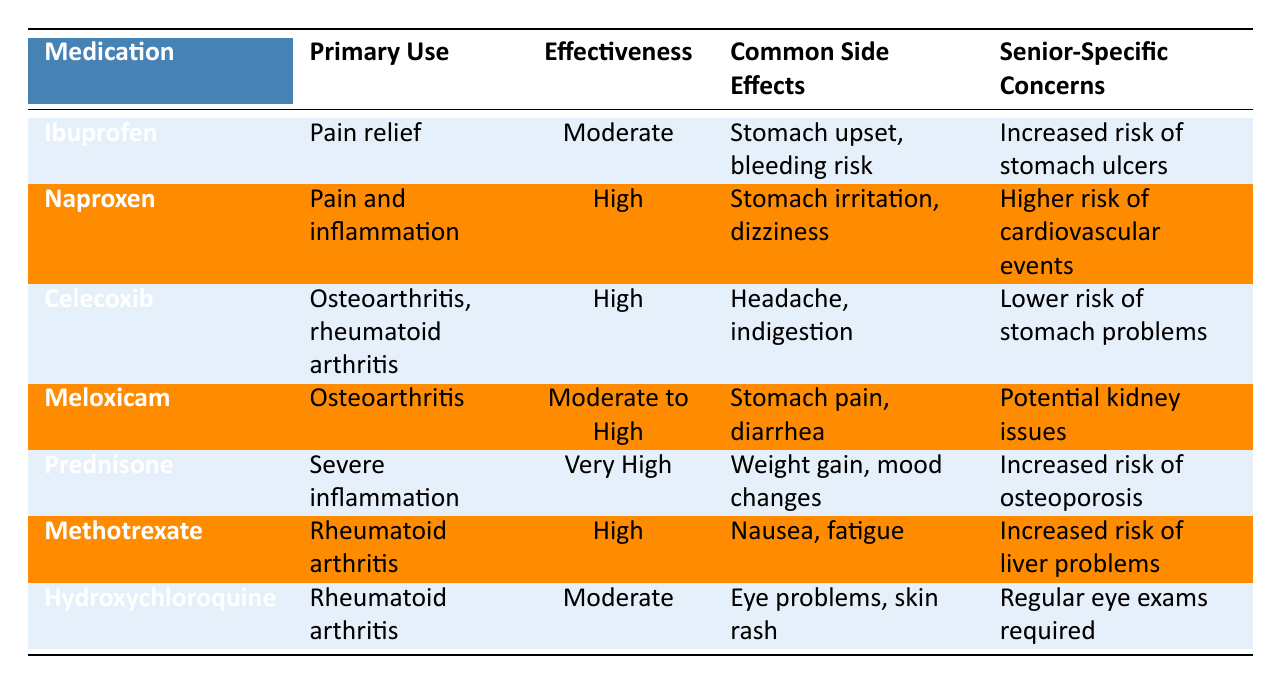What is the effectiveness rating of Prednisone? The table shows that the effectiveness rating of Prednisone is listed as "Very High."
Answer: Very High Which medication has a lower risk of stomach problems? The table indicates that Celecoxib has a "Lower risk of stomach problems" noted in its senior-specific concerns.
Answer: Celecoxib Is Meloxicam used for rheumatoid arthritis? The primary use of Meloxicam, according to the table, is "Osteoarthritis," indicating it is not specifically used for rheumatoid arthritis.
Answer: No What are the common side effects of Naproxen? According to the table, the common side effects listed for Naproxen are "Stomach irritation, dizziness."
Answer: Stomach irritation, dizziness How does the effectiveness of Methotrexate compare to Ibuprofen? The effectiveness rating for Methotrexate is "High," while for Ibuprofen it is "Moderate." Thus, Methotrexate is more effective than Ibuprofen.
Answer: Methotrexate is more effective Which medication has the highest effectiveness for severe inflammation? The table shows that Prednisone has the highest effectiveness rating listed as "Very High" for severe inflammation.
Answer: Prednisone Are the common side effects of Hydroxychloroquine worse than those of Celecoxib? Hydroxychloroquine has side effects of "Eye problems, skin rash," while Celecoxib has "Headache, indigestion." Although both have adverse effects, Hydroxychloroquine's issues may be seen as more serious because they involve potential vision impairment.
Answer: Yes What is the total number of medications listed for rheumatoid arthritis? The table lists two medications for rheumatoid arthritis: Methotrexate and Hydroxychloroquine. Therefore, the total is 2.
Answer: 2 What are the senior-specific concerns related to Prednisone and Meloxicam? The table indicates Prednisone has "Increased risk of osteoporosis" while Meloxicam has "Potential kidney issues."
Answer: Osteoporosis, kidney issues 